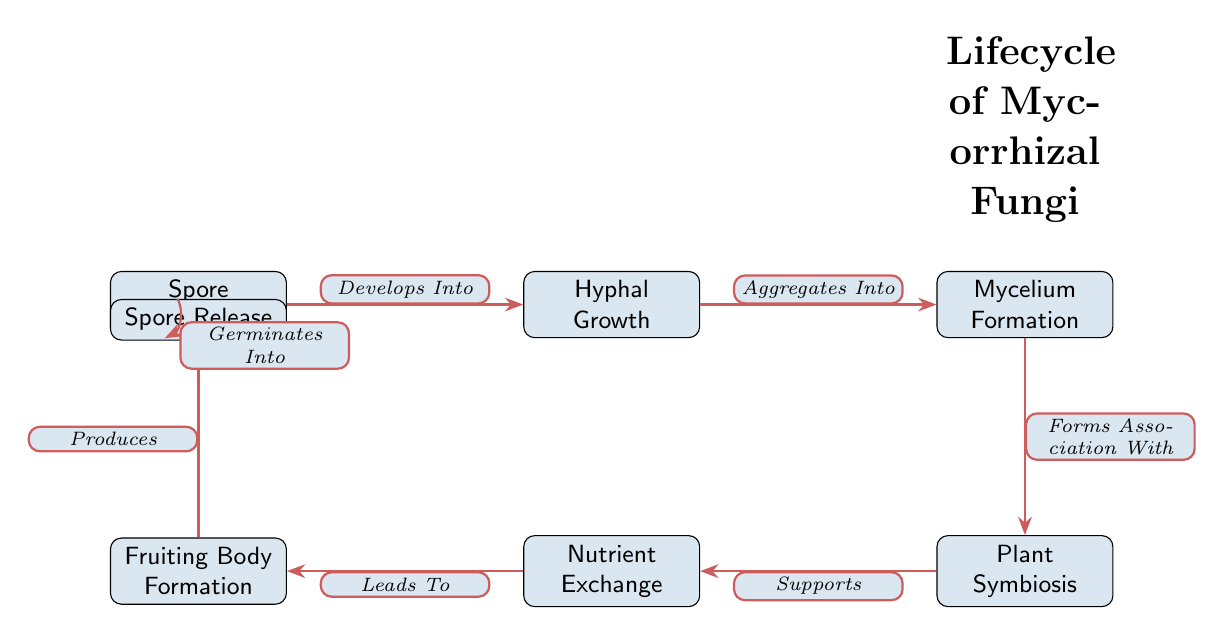What is the first stage in the lifecycle of mycorrhizal fungi? The diagram shows "Spore Germination" as the first node, indicating this is the initial stage in the lifecycle.
Answer: Spore Germination How many relationships are depicted between the stages? By counting the edges connecting the nodes in the diagram, there are six relationships indicated by the arrows.
Answer: 6 What does "Fruiting Body Formation" lead to? The diagram shows an arrow labeled "Produces" pointing from "Fruiting Body Formation" to "Spore Release," indicating it leads to this stage.
Answer: Spore Release Which stage comes after "Hyphal Growth"? Following the "Hyphal Growth" node in the diagram, the next node is "Mycelium Formation," illustrating the sequence of development.
Answer: Mycelium Formation What is exchanged during "Plant Symbiosis"? According to the diagram, "Plant Symbiosis" supports "Nutrient Exchange," implying nutrients are exchanged between the plant and the fungi.
Answer: Nutrients What stage forms an association with plants? The node "Mycelium Formation" has an edge labeled "Forms Association With" pointing to "Plant Symbiosis," indicating this is the stage that forms such an association.
Answer: Mycelium Formation How does the lifecycle return to the start? The diagram shows a cycle from "Spore Release," which "Germinates Into" the initial stage "Spore Germination," thus completing the lifecycle.
Answer: Spore Germination What type of relationship exists between "Nutrient Exchange" and "Fruiting Body Formation"? The diagram indicates a directional relationship where "Nutrient Exchange" "Leads To" "Fruiting Body Formation," demonstrating a supportive role.
Answer: Leads To 